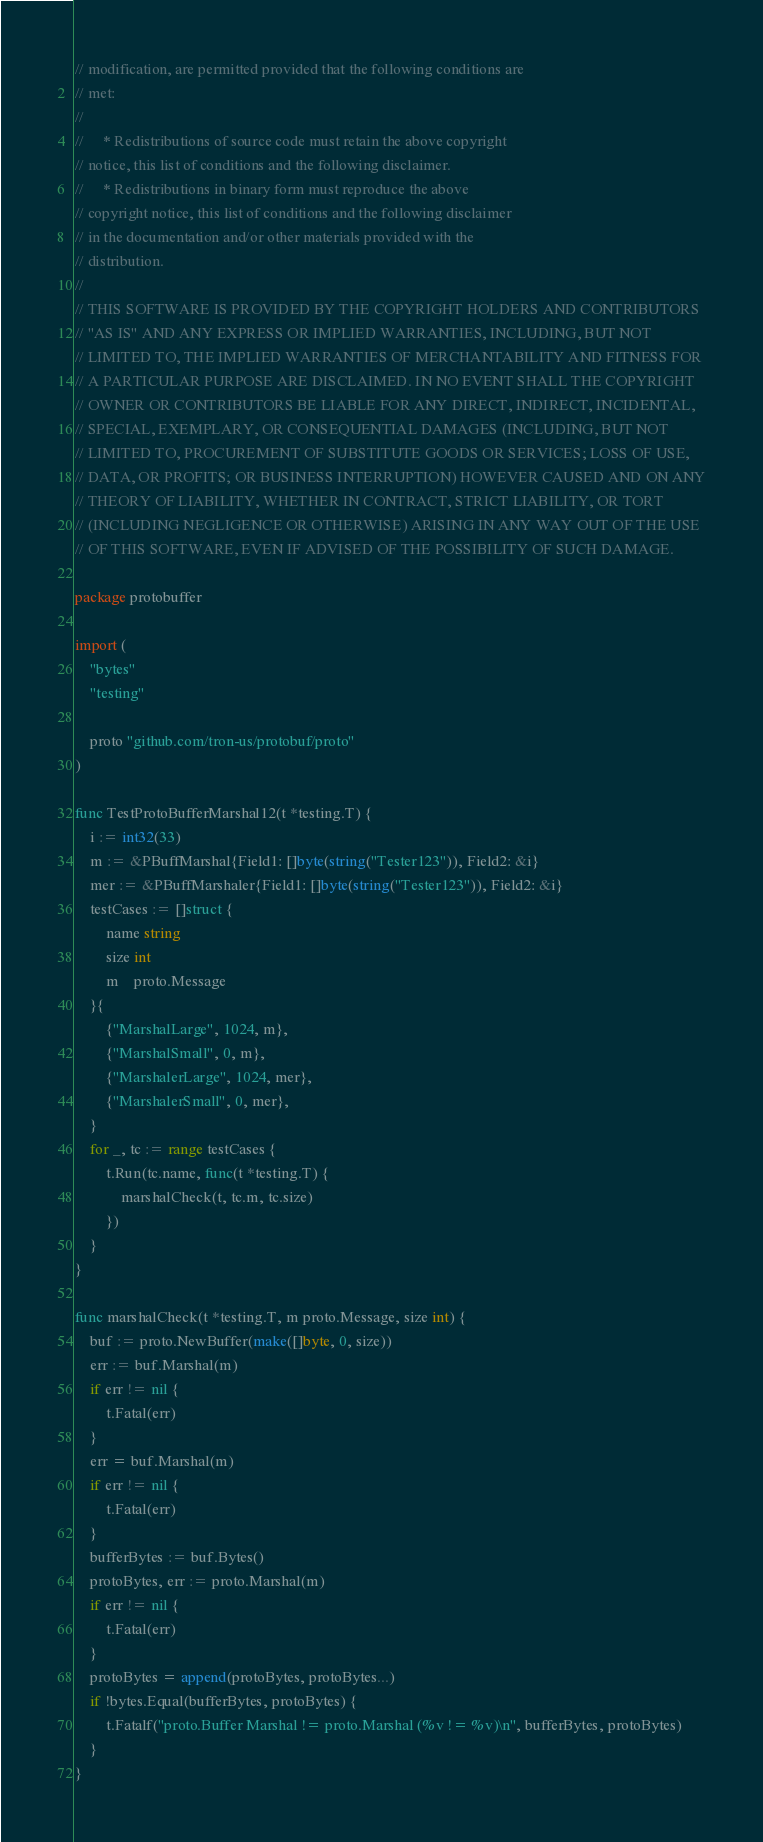Convert code to text. <code><loc_0><loc_0><loc_500><loc_500><_Go_>// modification, are permitted provided that the following conditions are
// met:
//
//     * Redistributions of source code must retain the above copyright
// notice, this list of conditions and the following disclaimer.
//     * Redistributions in binary form must reproduce the above
// copyright notice, this list of conditions and the following disclaimer
// in the documentation and/or other materials provided with the
// distribution.
//
// THIS SOFTWARE IS PROVIDED BY THE COPYRIGHT HOLDERS AND CONTRIBUTORS
// "AS IS" AND ANY EXPRESS OR IMPLIED WARRANTIES, INCLUDING, BUT NOT
// LIMITED TO, THE IMPLIED WARRANTIES OF MERCHANTABILITY AND FITNESS FOR
// A PARTICULAR PURPOSE ARE DISCLAIMED. IN NO EVENT SHALL THE COPYRIGHT
// OWNER OR CONTRIBUTORS BE LIABLE FOR ANY DIRECT, INDIRECT, INCIDENTAL,
// SPECIAL, EXEMPLARY, OR CONSEQUENTIAL DAMAGES (INCLUDING, BUT NOT
// LIMITED TO, PROCUREMENT OF SUBSTITUTE GOODS OR SERVICES; LOSS OF USE,
// DATA, OR PROFITS; OR BUSINESS INTERRUPTION) HOWEVER CAUSED AND ON ANY
// THEORY OF LIABILITY, WHETHER IN CONTRACT, STRICT LIABILITY, OR TORT
// (INCLUDING NEGLIGENCE OR OTHERWISE) ARISING IN ANY WAY OUT OF THE USE
// OF THIS SOFTWARE, EVEN IF ADVISED OF THE POSSIBILITY OF SUCH DAMAGE.

package protobuffer

import (
	"bytes"
	"testing"

	proto "github.com/tron-us/protobuf/proto"
)

func TestProtoBufferMarshal12(t *testing.T) {
	i := int32(33)
	m := &PBuffMarshal{Field1: []byte(string("Tester123")), Field2: &i}
	mer := &PBuffMarshaler{Field1: []byte(string("Tester123")), Field2: &i}
	testCases := []struct {
		name string
		size int
		m    proto.Message
	}{
		{"MarshalLarge", 1024, m},
		{"MarshalSmall", 0, m},
		{"MarshalerLarge", 1024, mer},
		{"MarshalerSmall", 0, mer},
	}
	for _, tc := range testCases {
		t.Run(tc.name, func(t *testing.T) {
			marshalCheck(t, tc.m, tc.size)
		})
	}
}

func marshalCheck(t *testing.T, m proto.Message, size int) {
	buf := proto.NewBuffer(make([]byte, 0, size))
	err := buf.Marshal(m)
	if err != nil {
		t.Fatal(err)
	}
	err = buf.Marshal(m)
	if err != nil {
		t.Fatal(err)
	}
	bufferBytes := buf.Bytes()
	protoBytes, err := proto.Marshal(m)
	if err != nil {
		t.Fatal(err)
	}
	protoBytes = append(protoBytes, protoBytes...)
	if !bytes.Equal(bufferBytes, protoBytes) {
		t.Fatalf("proto.Buffer Marshal != proto.Marshal (%v != %v)\n", bufferBytes, protoBytes)
	}
}
</code> 